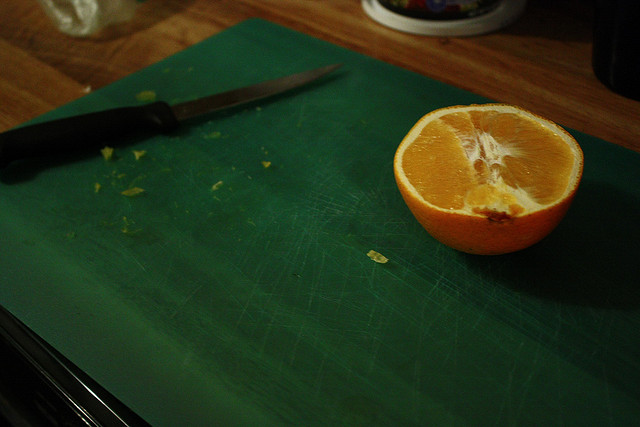How can you tell if a Navel orange is ripe and ready to eat? A ripe Navel orange will feel firm, have a slightly heavy feel for its size, and possess a vibrant orange color without major blemishes. The skin should feel slightly pebbly with an aromatic scent. 